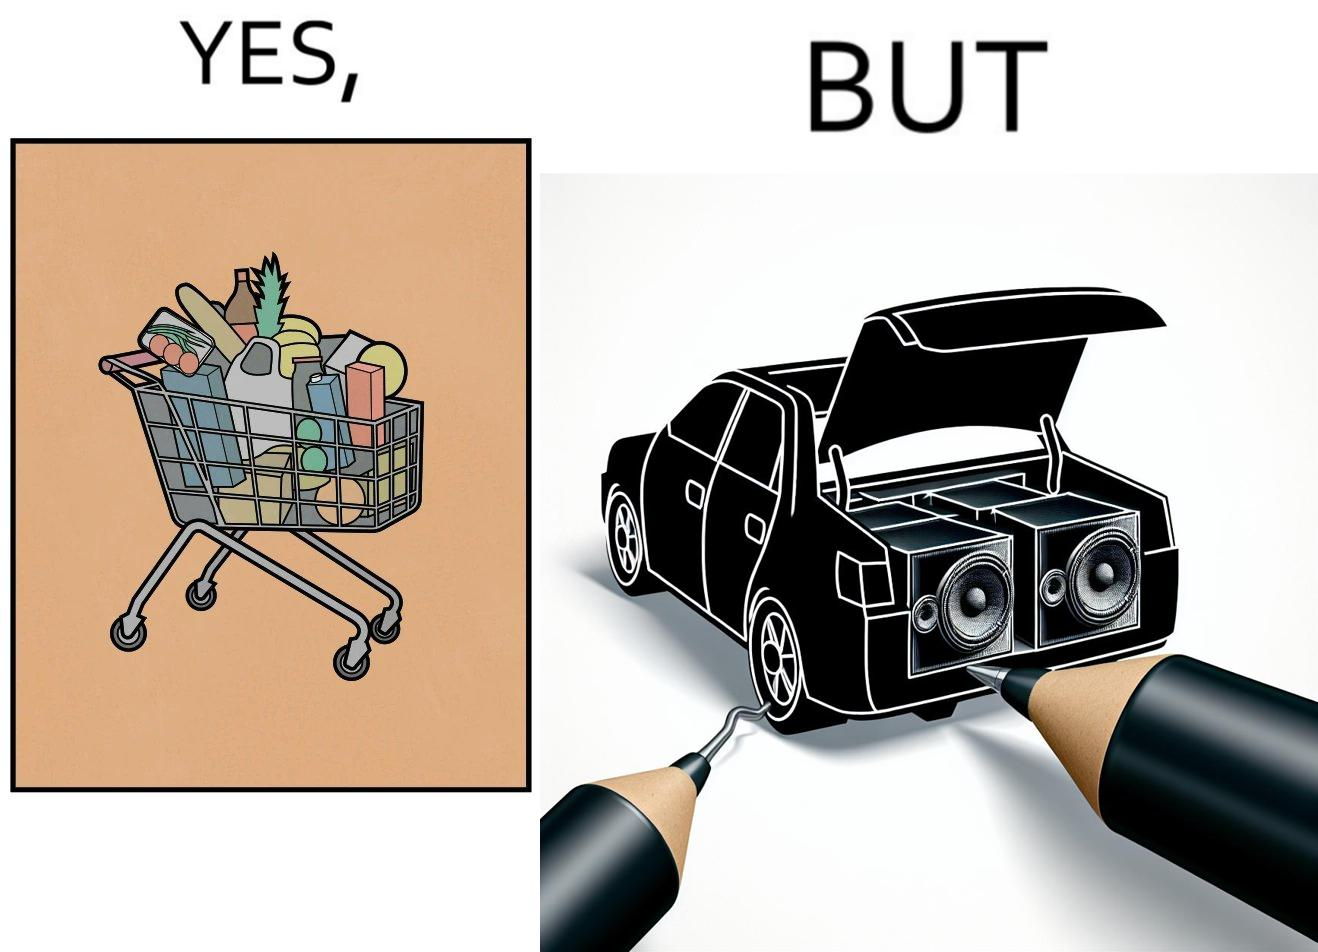Describe the contrast between the left and right parts of this image. In the left part of the image: a shopping cart full of items In the right part of the image: a black car with its trunk lid open and some boxes, probably speakers, kept in the trunk 